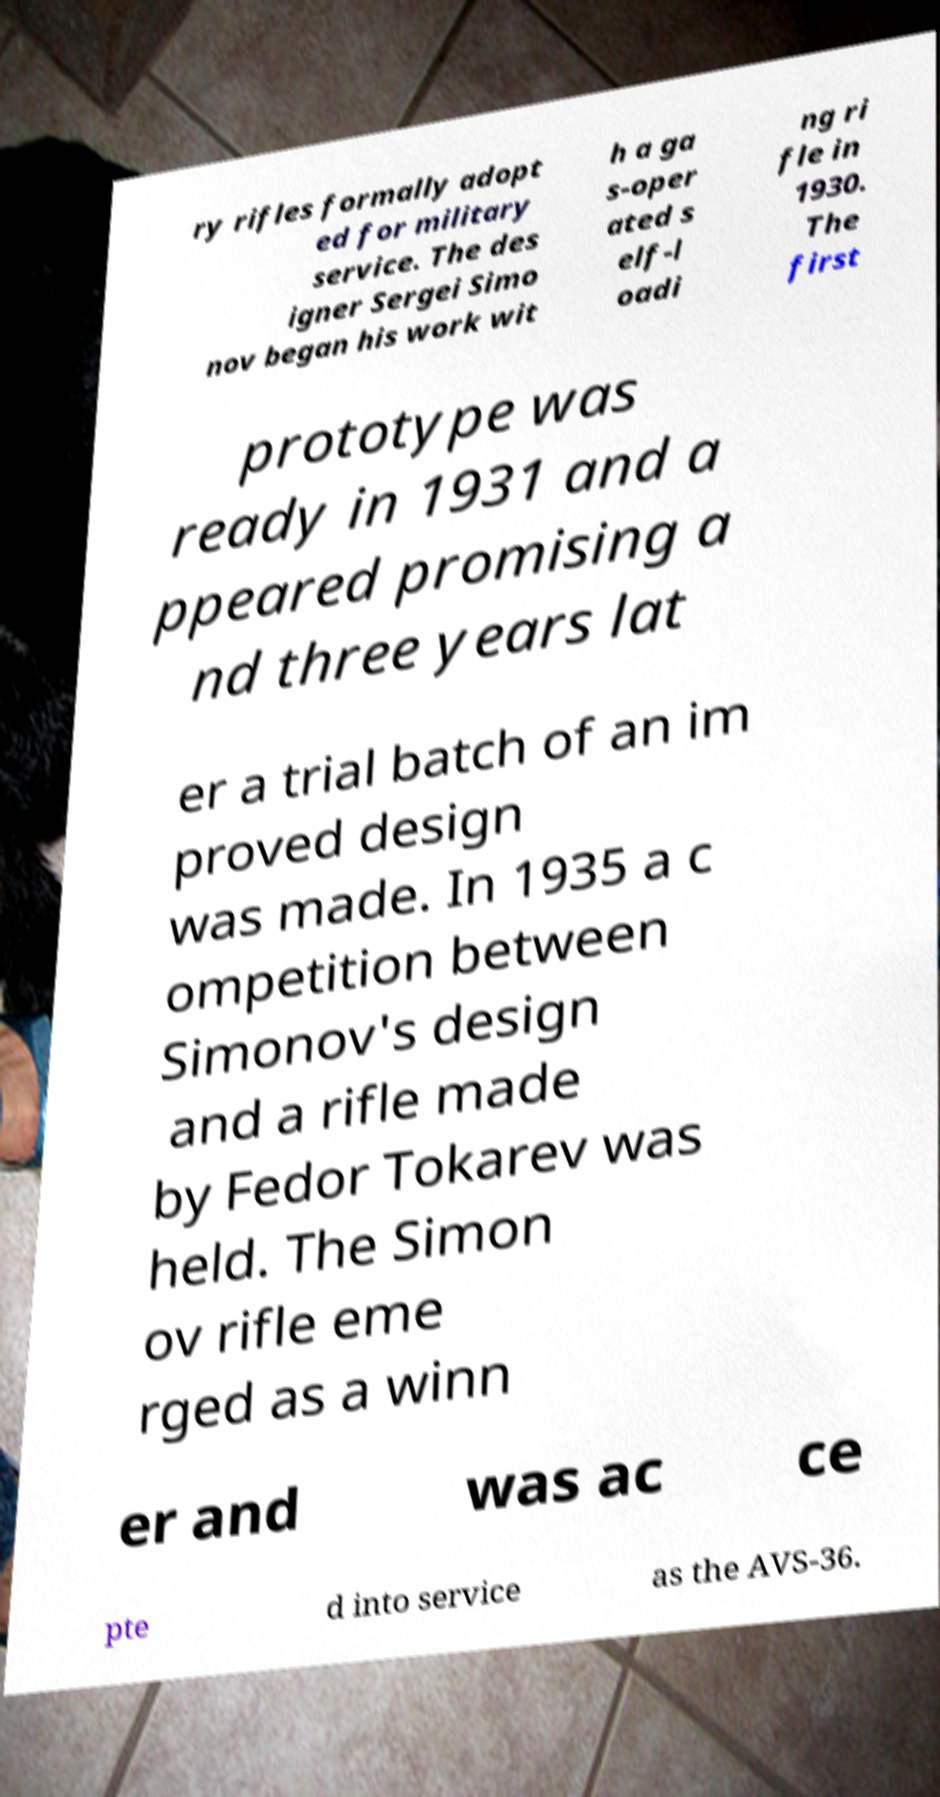Could you assist in decoding the text presented in this image and type it out clearly? ry rifles formally adopt ed for military service. The des igner Sergei Simo nov began his work wit h a ga s-oper ated s elf-l oadi ng ri fle in 1930. The first prototype was ready in 1931 and a ppeared promising a nd three years lat er a trial batch of an im proved design was made. In 1935 a c ompetition between Simonov's design and a rifle made by Fedor Tokarev was held. The Simon ov rifle eme rged as a winn er and was ac ce pte d into service as the AVS-36. 